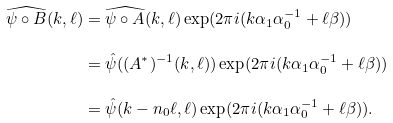Convert formula to latex. <formula><loc_0><loc_0><loc_500><loc_500>\widehat { \psi \circ B } ( k , \ell ) & = \widehat { \psi \circ A } ( k , \ell ) \exp ( 2 \pi i ( k \alpha _ { 1 } \alpha _ { 0 } ^ { - 1 } + \ell \beta ) ) \\ & = \hat { \psi } ( ( A ^ { * } ) ^ { - 1 } ( k , \ell ) ) \exp ( 2 \pi i ( k \alpha _ { 1 } \alpha _ { 0 } ^ { - 1 } + \ell \beta ) ) \\ & = \hat { \psi } ( k - n _ { 0 } \ell , \ell ) \exp ( 2 \pi i ( k \alpha _ { 1 } \alpha _ { 0 } ^ { - 1 } + \ell \beta ) ) .</formula> 